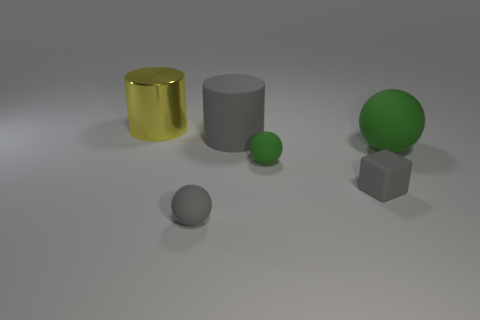Add 3 gray matte cylinders. How many objects exist? 9 Add 6 big green rubber things. How many big green rubber things exist? 7 Subtract all green balls. How many balls are left? 1 Subtract all gray balls. How many balls are left? 2 Subtract 1 yellow cylinders. How many objects are left? 5 Subtract all cylinders. How many objects are left? 4 Subtract 3 balls. How many balls are left? 0 Subtract all red cubes. Subtract all cyan spheres. How many cubes are left? 1 Subtract all green spheres. How many red cylinders are left? 0 Subtract all small yellow matte objects. Subtract all matte spheres. How many objects are left? 3 